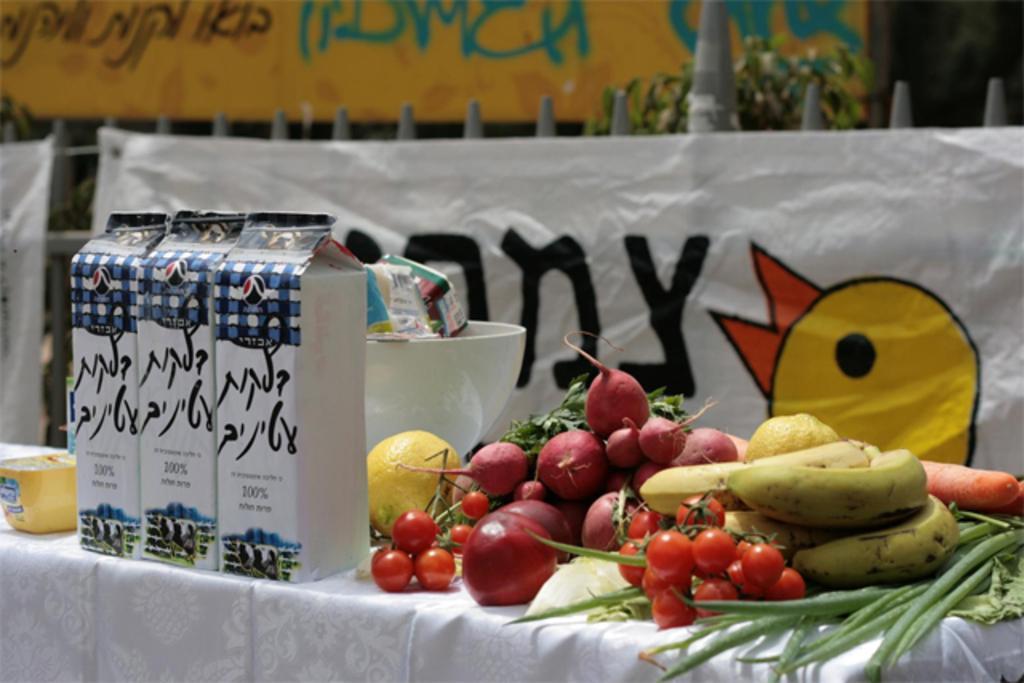Describe this image in one or two sentences. In this image on the right side there are some fruits and on the left side there are some packet. 